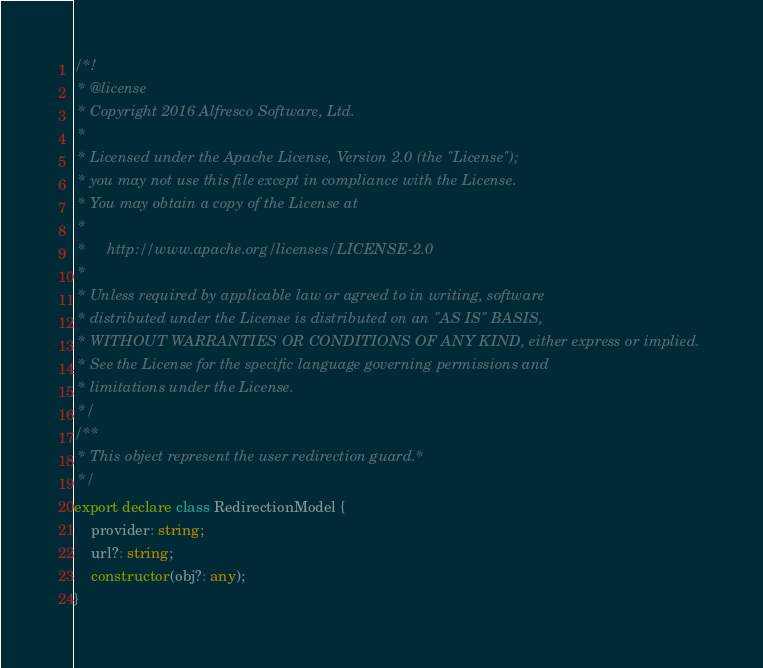Convert code to text. <code><loc_0><loc_0><loc_500><loc_500><_TypeScript_>/*!
 * @license
 * Copyright 2016 Alfresco Software, Ltd.
 *
 * Licensed under the Apache License, Version 2.0 (the "License");
 * you may not use this file except in compliance with the License.
 * You may obtain a copy of the License at
 *
 *     http://www.apache.org/licenses/LICENSE-2.0
 *
 * Unless required by applicable law or agreed to in writing, software
 * distributed under the License is distributed on an "AS IS" BASIS,
 * WITHOUT WARRANTIES OR CONDITIONS OF ANY KIND, either express or implied.
 * See the License for the specific language governing permissions and
 * limitations under the License.
 */
/**
 * This object represent the user redirection guard.*
 */
export declare class RedirectionModel {
    provider: string;
    url?: string;
    constructor(obj?: any);
}
</code> 